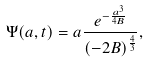Convert formula to latex. <formula><loc_0><loc_0><loc_500><loc_500>\Psi ( a , t ) = a \frac { e ^ { - \frac { a ^ { 3 } } { 4 B } } } { ( - 2 B ) ^ { \frac { 4 } { 3 } } } ,</formula> 